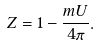<formula> <loc_0><loc_0><loc_500><loc_500>Z = 1 - \frac { m U } { 4 \pi } .</formula> 